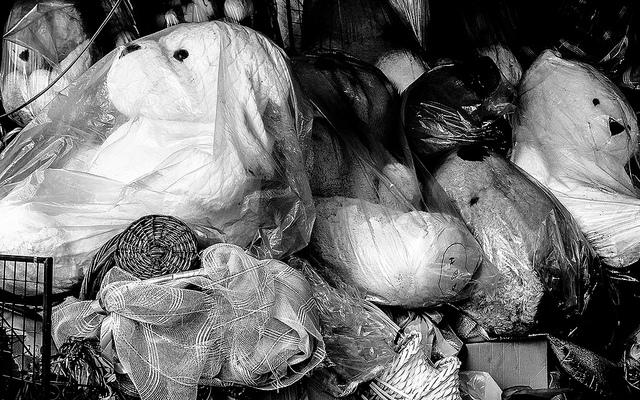Where is the wicket basket?
Concise answer only. Middle. Are these toys the same color?
Write a very short answer. No. What is in the plastic bags?
Short answer required. Stuffed animals. 